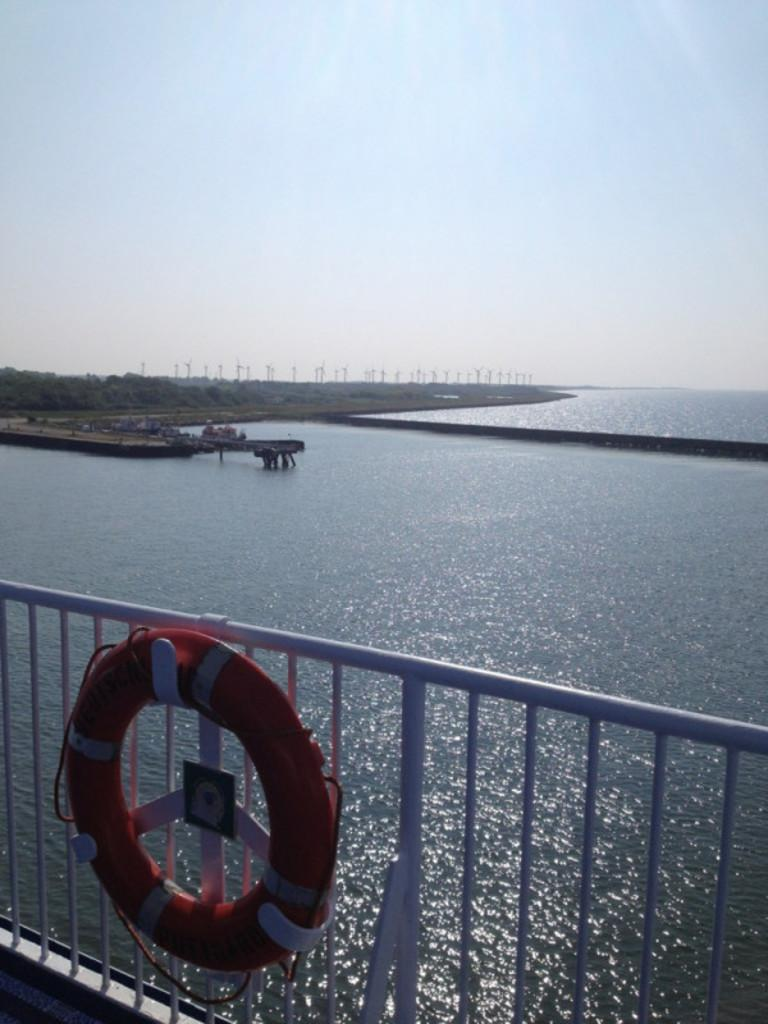What object is attached to the fence in the image? There is a tube on a fence in the image. What can be seen in the foreground of the image? Water is visible in the image. What type of vegetation is in the background of the image? There are trees in the background of the image. What is visible in the sky in the image? The sky is visible in the background of the image. What type of linen is draped over the tube in the image? There is no linen present in the image; the tube is directly attached to the fence. 